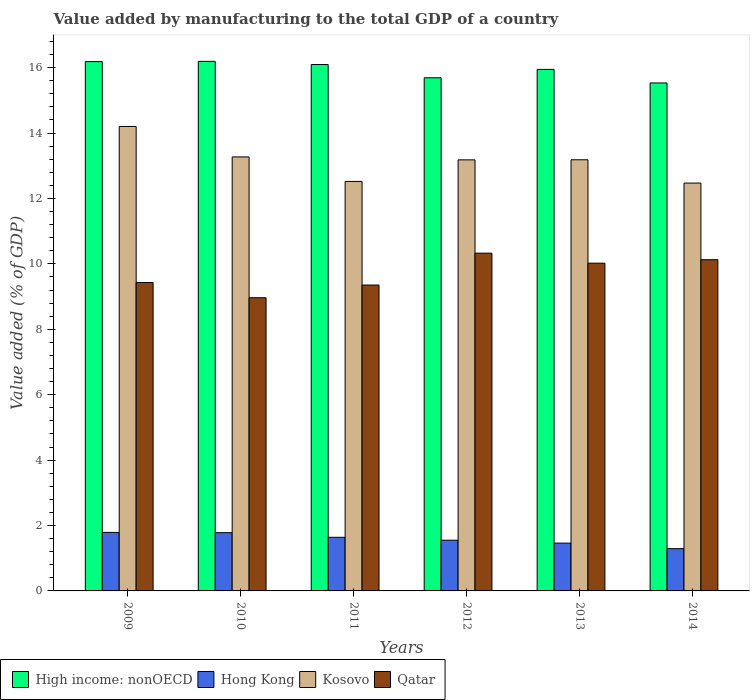Are the number of bars per tick equal to the number of legend labels?
Your answer should be compact. Yes. How many bars are there on the 2nd tick from the left?
Offer a terse response. 4. What is the value added by manufacturing to the total GDP in Qatar in 2009?
Provide a short and direct response. 9.43. Across all years, what is the maximum value added by manufacturing to the total GDP in Kosovo?
Offer a terse response. 14.2. Across all years, what is the minimum value added by manufacturing to the total GDP in Qatar?
Keep it short and to the point. 8.97. What is the total value added by manufacturing to the total GDP in Qatar in the graph?
Give a very brief answer. 58.23. What is the difference between the value added by manufacturing to the total GDP in High income: nonOECD in 2009 and that in 2014?
Provide a succinct answer. 0.65. What is the difference between the value added by manufacturing to the total GDP in High income: nonOECD in 2011 and the value added by manufacturing to the total GDP in Qatar in 2012?
Your answer should be compact. 5.77. What is the average value added by manufacturing to the total GDP in Hong Kong per year?
Provide a short and direct response. 1.59. In the year 2012, what is the difference between the value added by manufacturing to the total GDP in Qatar and value added by manufacturing to the total GDP in High income: nonOECD?
Your answer should be very brief. -5.36. What is the ratio of the value added by manufacturing to the total GDP in Qatar in 2010 to that in 2011?
Your answer should be compact. 0.96. What is the difference between the highest and the second highest value added by manufacturing to the total GDP in Qatar?
Your answer should be very brief. 0.2. What is the difference between the highest and the lowest value added by manufacturing to the total GDP in High income: nonOECD?
Your answer should be compact. 0.66. In how many years, is the value added by manufacturing to the total GDP in Kosovo greater than the average value added by manufacturing to the total GDP in Kosovo taken over all years?
Make the answer very short. 4. Is the sum of the value added by manufacturing to the total GDP in High income: nonOECD in 2012 and 2013 greater than the maximum value added by manufacturing to the total GDP in Qatar across all years?
Offer a terse response. Yes. What does the 4th bar from the left in 2011 represents?
Offer a terse response. Qatar. What does the 3rd bar from the right in 2012 represents?
Offer a terse response. Hong Kong. How many years are there in the graph?
Make the answer very short. 6. Where does the legend appear in the graph?
Your answer should be very brief. Bottom left. What is the title of the graph?
Give a very brief answer. Value added by manufacturing to the total GDP of a country. What is the label or title of the X-axis?
Offer a terse response. Years. What is the label or title of the Y-axis?
Provide a short and direct response. Value added (% of GDP). What is the Value added (% of GDP) in High income: nonOECD in 2009?
Ensure brevity in your answer.  16.19. What is the Value added (% of GDP) in Hong Kong in 2009?
Your answer should be compact. 1.79. What is the Value added (% of GDP) in Kosovo in 2009?
Make the answer very short. 14.2. What is the Value added (% of GDP) in Qatar in 2009?
Offer a terse response. 9.43. What is the Value added (% of GDP) in High income: nonOECD in 2010?
Make the answer very short. 16.19. What is the Value added (% of GDP) of Hong Kong in 2010?
Ensure brevity in your answer.  1.78. What is the Value added (% of GDP) in Kosovo in 2010?
Make the answer very short. 13.27. What is the Value added (% of GDP) of Qatar in 2010?
Offer a very short reply. 8.97. What is the Value added (% of GDP) of High income: nonOECD in 2011?
Provide a succinct answer. 16.1. What is the Value added (% of GDP) in Hong Kong in 2011?
Make the answer very short. 1.64. What is the Value added (% of GDP) in Kosovo in 2011?
Offer a terse response. 12.52. What is the Value added (% of GDP) of Qatar in 2011?
Your answer should be very brief. 9.35. What is the Value added (% of GDP) of High income: nonOECD in 2012?
Keep it short and to the point. 15.69. What is the Value added (% of GDP) in Hong Kong in 2012?
Ensure brevity in your answer.  1.55. What is the Value added (% of GDP) in Kosovo in 2012?
Ensure brevity in your answer.  13.18. What is the Value added (% of GDP) in Qatar in 2012?
Make the answer very short. 10.33. What is the Value added (% of GDP) of High income: nonOECD in 2013?
Offer a terse response. 15.95. What is the Value added (% of GDP) of Hong Kong in 2013?
Ensure brevity in your answer.  1.46. What is the Value added (% of GDP) of Kosovo in 2013?
Provide a succinct answer. 13.18. What is the Value added (% of GDP) of Qatar in 2013?
Give a very brief answer. 10.02. What is the Value added (% of GDP) of High income: nonOECD in 2014?
Keep it short and to the point. 15.53. What is the Value added (% of GDP) of Hong Kong in 2014?
Make the answer very short. 1.29. What is the Value added (% of GDP) in Kosovo in 2014?
Provide a succinct answer. 12.47. What is the Value added (% of GDP) of Qatar in 2014?
Offer a terse response. 10.13. Across all years, what is the maximum Value added (% of GDP) of High income: nonOECD?
Offer a very short reply. 16.19. Across all years, what is the maximum Value added (% of GDP) of Hong Kong?
Offer a very short reply. 1.79. Across all years, what is the maximum Value added (% of GDP) in Kosovo?
Your answer should be compact. 14.2. Across all years, what is the maximum Value added (% of GDP) in Qatar?
Offer a terse response. 10.33. Across all years, what is the minimum Value added (% of GDP) of High income: nonOECD?
Your answer should be compact. 15.53. Across all years, what is the minimum Value added (% of GDP) of Hong Kong?
Your answer should be compact. 1.29. Across all years, what is the minimum Value added (% of GDP) in Kosovo?
Offer a very short reply. 12.47. Across all years, what is the minimum Value added (% of GDP) in Qatar?
Offer a very short reply. 8.97. What is the total Value added (% of GDP) in High income: nonOECD in the graph?
Provide a short and direct response. 95.64. What is the total Value added (% of GDP) of Hong Kong in the graph?
Keep it short and to the point. 9.51. What is the total Value added (% of GDP) in Kosovo in the graph?
Your answer should be compact. 78.83. What is the total Value added (% of GDP) in Qatar in the graph?
Provide a short and direct response. 58.23. What is the difference between the Value added (% of GDP) in High income: nonOECD in 2009 and that in 2010?
Provide a succinct answer. -0.01. What is the difference between the Value added (% of GDP) in Hong Kong in 2009 and that in 2010?
Provide a short and direct response. 0.01. What is the difference between the Value added (% of GDP) of Kosovo in 2009 and that in 2010?
Keep it short and to the point. 0.93. What is the difference between the Value added (% of GDP) in Qatar in 2009 and that in 2010?
Offer a terse response. 0.46. What is the difference between the Value added (% of GDP) in High income: nonOECD in 2009 and that in 2011?
Keep it short and to the point. 0.09. What is the difference between the Value added (% of GDP) in Kosovo in 2009 and that in 2011?
Give a very brief answer. 1.68. What is the difference between the Value added (% of GDP) of Qatar in 2009 and that in 2011?
Offer a terse response. 0.08. What is the difference between the Value added (% of GDP) in High income: nonOECD in 2009 and that in 2012?
Keep it short and to the point. 0.5. What is the difference between the Value added (% of GDP) in Hong Kong in 2009 and that in 2012?
Offer a very short reply. 0.24. What is the difference between the Value added (% of GDP) in Kosovo in 2009 and that in 2012?
Offer a terse response. 1.02. What is the difference between the Value added (% of GDP) of Qatar in 2009 and that in 2012?
Give a very brief answer. -0.9. What is the difference between the Value added (% of GDP) in High income: nonOECD in 2009 and that in 2013?
Keep it short and to the point. 0.24. What is the difference between the Value added (% of GDP) in Hong Kong in 2009 and that in 2013?
Your answer should be very brief. 0.33. What is the difference between the Value added (% of GDP) of Kosovo in 2009 and that in 2013?
Your answer should be compact. 1.02. What is the difference between the Value added (% of GDP) in Qatar in 2009 and that in 2013?
Provide a succinct answer. -0.59. What is the difference between the Value added (% of GDP) of High income: nonOECD in 2009 and that in 2014?
Offer a very short reply. 0.65. What is the difference between the Value added (% of GDP) of Hong Kong in 2009 and that in 2014?
Your response must be concise. 0.5. What is the difference between the Value added (% of GDP) in Kosovo in 2009 and that in 2014?
Your answer should be very brief. 1.73. What is the difference between the Value added (% of GDP) in Qatar in 2009 and that in 2014?
Your answer should be very brief. -0.7. What is the difference between the Value added (% of GDP) in High income: nonOECD in 2010 and that in 2011?
Ensure brevity in your answer.  0.1. What is the difference between the Value added (% of GDP) in Hong Kong in 2010 and that in 2011?
Provide a short and direct response. 0.14. What is the difference between the Value added (% of GDP) in Kosovo in 2010 and that in 2011?
Keep it short and to the point. 0.75. What is the difference between the Value added (% of GDP) in Qatar in 2010 and that in 2011?
Your answer should be compact. -0.39. What is the difference between the Value added (% of GDP) of High income: nonOECD in 2010 and that in 2012?
Offer a very short reply. 0.5. What is the difference between the Value added (% of GDP) in Hong Kong in 2010 and that in 2012?
Offer a terse response. 0.23. What is the difference between the Value added (% of GDP) of Kosovo in 2010 and that in 2012?
Offer a very short reply. 0.09. What is the difference between the Value added (% of GDP) in Qatar in 2010 and that in 2012?
Ensure brevity in your answer.  -1.36. What is the difference between the Value added (% of GDP) of High income: nonOECD in 2010 and that in 2013?
Your response must be concise. 0.25. What is the difference between the Value added (% of GDP) in Hong Kong in 2010 and that in 2013?
Ensure brevity in your answer.  0.32. What is the difference between the Value added (% of GDP) of Kosovo in 2010 and that in 2013?
Make the answer very short. 0.09. What is the difference between the Value added (% of GDP) in Qatar in 2010 and that in 2013?
Give a very brief answer. -1.06. What is the difference between the Value added (% of GDP) of High income: nonOECD in 2010 and that in 2014?
Provide a short and direct response. 0.66. What is the difference between the Value added (% of GDP) of Hong Kong in 2010 and that in 2014?
Provide a succinct answer. 0.49. What is the difference between the Value added (% of GDP) of Qatar in 2010 and that in 2014?
Provide a succinct answer. -1.16. What is the difference between the Value added (% of GDP) in High income: nonOECD in 2011 and that in 2012?
Offer a very short reply. 0.4. What is the difference between the Value added (% of GDP) in Hong Kong in 2011 and that in 2012?
Ensure brevity in your answer.  0.09. What is the difference between the Value added (% of GDP) in Kosovo in 2011 and that in 2012?
Your answer should be very brief. -0.66. What is the difference between the Value added (% of GDP) in Qatar in 2011 and that in 2012?
Give a very brief answer. -0.98. What is the difference between the Value added (% of GDP) of High income: nonOECD in 2011 and that in 2013?
Your response must be concise. 0.15. What is the difference between the Value added (% of GDP) of Hong Kong in 2011 and that in 2013?
Keep it short and to the point. 0.18. What is the difference between the Value added (% of GDP) in Kosovo in 2011 and that in 2013?
Your answer should be very brief. -0.66. What is the difference between the Value added (% of GDP) of Qatar in 2011 and that in 2013?
Your answer should be compact. -0.67. What is the difference between the Value added (% of GDP) in High income: nonOECD in 2011 and that in 2014?
Your response must be concise. 0.56. What is the difference between the Value added (% of GDP) in Hong Kong in 2011 and that in 2014?
Ensure brevity in your answer.  0.35. What is the difference between the Value added (% of GDP) in Kosovo in 2011 and that in 2014?
Ensure brevity in your answer.  0.05. What is the difference between the Value added (% of GDP) in Qatar in 2011 and that in 2014?
Your answer should be compact. -0.77. What is the difference between the Value added (% of GDP) in High income: nonOECD in 2012 and that in 2013?
Provide a succinct answer. -0.26. What is the difference between the Value added (% of GDP) of Hong Kong in 2012 and that in 2013?
Keep it short and to the point. 0.09. What is the difference between the Value added (% of GDP) in Kosovo in 2012 and that in 2013?
Offer a very short reply. -0. What is the difference between the Value added (% of GDP) of Qatar in 2012 and that in 2013?
Offer a very short reply. 0.31. What is the difference between the Value added (% of GDP) in High income: nonOECD in 2012 and that in 2014?
Provide a short and direct response. 0.16. What is the difference between the Value added (% of GDP) of Hong Kong in 2012 and that in 2014?
Provide a succinct answer. 0.26. What is the difference between the Value added (% of GDP) in Kosovo in 2012 and that in 2014?
Your answer should be very brief. 0.71. What is the difference between the Value added (% of GDP) of Qatar in 2012 and that in 2014?
Keep it short and to the point. 0.2. What is the difference between the Value added (% of GDP) in High income: nonOECD in 2013 and that in 2014?
Make the answer very short. 0.41. What is the difference between the Value added (% of GDP) of Hong Kong in 2013 and that in 2014?
Provide a succinct answer. 0.17. What is the difference between the Value added (% of GDP) in Kosovo in 2013 and that in 2014?
Your answer should be compact. 0.71. What is the difference between the Value added (% of GDP) in Qatar in 2013 and that in 2014?
Keep it short and to the point. -0.11. What is the difference between the Value added (% of GDP) in High income: nonOECD in 2009 and the Value added (% of GDP) in Hong Kong in 2010?
Your response must be concise. 14.41. What is the difference between the Value added (% of GDP) in High income: nonOECD in 2009 and the Value added (% of GDP) in Kosovo in 2010?
Keep it short and to the point. 2.92. What is the difference between the Value added (% of GDP) of High income: nonOECD in 2009 and the Value added (% of GDP) of Qatar in 2010?
Make the answer very short. 7.22. What is the difference between the Value added (% of GDP) in Hong Kong in 2009 and the Value added (% of GDP) in Kosovo in 2010?
Provide a succinct answer. -11.48. What is the difference between the Value added (% of GDP) in Hong Kong in 2009 and the Value added (% of GDP) in Qatar in 2010?
Ensure brevity in your answer.  -7.18. What is the difference between the Value added (% of GDP) in Kosovo in 2009 and the Value added (% of GDP) in Qatar in 2010?
Make the answer very short. 5.24. What is the difference between the Value added (% of GDP) in High income: nonOECD in 2009 and the Value added (% of GDP) in Hong Kong in 2011?
Offer a terse response. 14.55. What is the difference between the Value added (% of GDP) in High income: nonOECD in 2009 and the Value added (% of GDP) in Kosovo in 2011?
Your response must be concise. 3.66. What is the difference between the Value added (% of GDP) in High income: nonOECD in 2009 and the Value added (% of GDP) in Qatar in 2011?
Your response must be concise. 6.83. What is the difference between the Value added (% of GDP) in Hong Kong in 2009 and the Value added (% of GDP) in Kosovo in 2011?
Provide a succinct answer. -10.73. What is the difference between the Value added (% of GDP) of Hong Kong in 2009 and the Value added (% of GDP) of Qatar in 2011?
Give a very brief answer. -7.56. What is the difference between the Value added (% of GDP) in Kosovo in 2009 and the Value added (% of GDP) in Qatar in 2011?
Offer a terse response. 4.85. What is the difference between the Value added (% of GDP) in High income: nonOECD in 2009 and the Value added (% of GDP) in Hong Kong in 2012?
Make the answer very short. 14.64. What is the difference between the Value added (% of GDP) of High income: nonOECD in 2009 and the Value added (% of GDP) of Kosovo in 2012?
Your answer should be compact. 3. What is the difference between the Value added (% of GDP) of High income: nonOECD in 2009 and the Value added (% of GDP) of Qatar in 2012?
Provide a succinct answer. 5.86. What is the difference between the Value added (% of GDP) in Hong Kong in 2009 and the Value added (% of GDP) in Kosovo in 2012?
Make the answer very short. -11.39. What is the difference between the Value added (% of GDP) in Hong Kong in 2009 and the Value added (% of GDP) in Qatar in 2012?
Make the answer very short. -8.54. What is the difference between the Value added (% of GDP) of Kosovo in 2009 and the Value added (% of GDP) of Qatar in 2012?
Offer a very short reply. 3.87. What is the difference between the Value added (% of GDP) of High income: nonOECD in 2009 and the Value added (% of GDP) of Hong Kong in 2013?
Provide a succinct answer. 14.72. What is the difference between the Value added (% of GDP) of High income: nonOECD in 2009 and the Value added (% of GDP) of Kosovo in 2013?
Keep it short and to the point. 3. What is the difference between the Value added (% of GDP) in High income: nonOECD in 2009 and the Value added (% of GDP) in Qatar in 2013?
Provide a short and direct response. 6.16. What is the difference between the Value added (% of GDP) of Hong Kong in 2009 and the Value added (% of GDP) of Kosovo in 2013?
Ensure brevity in your answer.  -11.39. What is the difference between the Value added (% of GDP) of Hong Kong in 2009 and the Value added (% of GDP) of Qatar in 2013?
Offer a very short reply. -8.23. What is the difference between the Value added (% of GDP) in Kosovo in 2009 and the Value added (% of GDP) in Qatar in 2013?
Your answer should be very brief. 4.18. What is the difference between the Value added (% of GDP) of High income: nonOECD in 2009 and the Value added (% of GDP) of Hong Kong in 2014?
Your response must be concise. 14.89. What is the difference between the Value added (% of GDP) in High income: nonOECD in 2009 and the Value added (% of GDP) in Kosovo in 2014?
Offer a terse response. 3.72. What is the difference between the Value added (% of GDP) of High income: nonOECD in 2009 and the Value added (% of GDP) of Qatar in 2014?
Keep it short and to the point. 6.06. What is the difference between the Value added (% of GDP) of Hong Kong in 2009 and the Value added (% of GDP) of Kosovo in 2014?
Your answer should be compact. -10.68. What is the difference between the Value added (% of GDP) in Hong Kong in 2009 and the Value added (% of GDP) in Qatar in 2014?
Ensure brevity in your answer.  -8.34. What is the difference between the Value added (% of GDP) in Kosovo in 2009 and the Value added (% of GDP) in Qatar in 2014?
Provide a succinct answer. 4.07. What is the difference between the Value added (% of GDP) of High income: nonOECD in 2010 and the Value added (% of GDP) of Hong Kong in 2011?
Provide a short and direct response. 14.55. What is the difference between the Value added (% of GDP) in High income: nonOECD in 2010 and the Value added (% of GDP) in Kosovo in 2011?
Your answer should be very brief. 3.67. What is the difference between the Value added (% of GDP) of High income: nonOECD in 2010 and the Value added (% of GDP) of Qatar in 2011?
Provide a short and direct response. 6.84. What is the difference between the Value added (% of GDP) of Hong Kong in 2010 and the Value added (% of GDP) of Kosovo in 2011?
Provide a short and direct response. -10.74. What is the difference between the Value added (% of GDP) in Hong Kong in 2010 and the Value added (% of GDP) in Qatar in 2011?
Your answer should be compact. -7.57. What is the difference between the Value added (% of GDP) of Kosovo in 2010 and the Value added (% of GDP) of Qatar in 2011?
Provide a succinct answer. 3.92. What is the difference between the Value added (% of GDP) in High income: nonOECD in 2010 and the Value added (% of GDP) in Hong Kong in 2012?
Provide a succinct answer. 14.64. What is the difference between the Value added (% of GDP) in High income: nonOECD in 2010 and the Value added (% of GDP) in Kosovo in 2012?
Your response must be concise. 3.01. What is the difference between the Value added (% of GDP) of High income: nonOECD in 2010 and the Value added (% of GDP) of Qatar in 2012?
Your response must be concise. 5.86. What is the difference between the Value added (% of GDP) of Hong Kong in 2010 and the Value added (% of GDP) of Kosovo in 2012?
Give a very brief answer. -11.4. What is the difference between the Value added (% of GDP) in Hong Kong in 2010 and the Value added (% of GDP) in Qatar in 2012?
Keep it short and to the point. -8.55. What is the difference between the Value added (% of GDP) of Kosovo in 2010 and the Value added (% of GDP) of Qatar in 2012?
Offer a very short reply. 2.94. What is the difference between the Value added (% of GDP) of High income: nonOECD in 2010 and the Value added (% of GDP) of Hong Kong in 2013?
Give a very brief answer. 14.73. What is the difference between the Value added (% of GDP) of High income: nonOECD in 2010 and the Value added (% of GDP) of Kosovo in 2013?
Keep it short and to the point. 3.01. What is the difference between the Value added (% of GDP) of High income: nonOECD in 2010 and the Value added (% of GDP) of Qatar in 2013?
Your answer should be compact. 6.17. What is the difference between the Value added (% of GDP) in Hong Kong in 2010 and the Value added (% of GDP) in Kosovo in 2013?
Your response must be concise. -11.4. What is the difference between the Value added (% of GDP) of Hong Kong in 2010 and the Value added (% of GDP) of Qatar in 2013?
Make the answer very short. -8.24. What is the difference between the Value added (% of GDP) in Kosovo in 2010 and the Value added (% of GDP) in Qatar in 2013?
Keep it short and to the point. 3.25. What is the difference between the Value added (% of GDP) of High income: nonOECD in 2010 and the Value added (% of GDP) of Hong Kong in 2014?
Provide a succinct answer. 14.9. What is the difference between the Value added (% of GDP) in High income: nonOECD in 2010 and the Value added (% of GDP) in Kosovo in 2014?
Your answer should be compact. 3.72. What is the difference between the Value added (% of GDP) of High income: nonOECD in 2010 and the Value added (% of GDP) of Qatar in 2014?
Make the answer very short. 6.07. What is the difference between the Value added (% of GDP) of Hong Kong in 2010 and the Value added (% of GDP) of Kosovo in 2014?
Give a very brief answer. -10.69. What is the difference between the Value added (% of GDP) of Hong Kong in 2010 and the Value added (% of GDP) of Qatar in 2014?
Give a very brief answer. -8.35. What is the difference between the Value added (% of GDP) in Kosovo in 2010 and the Value added (% of GDP) in Qatar in 2014?
Your answer should be very brief. 3.14. What is the difference between the Value added (% of GDP) in High income: nonOECD in 2011 and the Value added (% of GDP) in Hong Kong in 2012?
Make the answer very short. 14.54. What is the difference between the Value added (% of GDP) in High income: nonOECD in 2011 and the Value added (% of GDP) in Kosovo in 2012?
Your answer should be compact. 2.91. What is the difference between the Value added (% of GDP) in High income: nonOECD in 2011 and the Value added (% of GDP) in Qatar in 2012?
Ensure brevity in your answer.  5.77. What is the difference between the Value added (% of GDP) in Hong Kong in 2011 and the Value added (% of GDP) in Kosovo in 2012?
Provide a succinct answer. -11.54. What is the difference between the Value added (% of GDP) of Hong Kong in 2011 and the Value added (% of GDP) of Qatar in 2012?
Provide a short and direct response. -8.69. What is the difference between the Value added (% of GDP) in Kosovo in 2011 and the Value added (% of GDP) in Qatar in 2012?
Ensure brevity in your answer.  2.19. What is the difference between the Value added (% of GDP) in High income: nonOECD in 2011 and the Value added (% of GDP) in Hong Kong in 2013?
Ensure brevity in your answer.  14.63. What is the difference between the Value added (% of GDP) in High income: nonOECD in 2011 and the Value added (% of GDP) in Kosovo in 2013?
Offer a very short reply. 2.91. What is the difference between the Value added (% of GDP) of High income: nonOECD in 2011 and the Value added (% of GDP) of Qatar in 2013?
Your response must be concise. 6.07. What is the difference between the Value added (% of GDP) in Hong Kong in 2011 and the Value added (% of GDP) in Kosovo in 2013?
Provide a short and direct response. -11.54. What is the difference between the Value added (% of GDP) in Hong Kong in 2011 and the Value added (% of GDP) in Qatar in 2013?
Provide a short and direct response. -8.38. What is the difference between the Value added (% of GDP) of Kosovo in 2011 and the Value added (% of GDP) of Qatar in 2013?
Provide a succinct answer. 2.5. What is the difference between the Value added (% of GDP) of High income: nonOECD in 2011 and the Value added (% of GDP) of Hong Kong in 2014?
Provide a short and direct response. 14.8. What is the difference between the Value added (% of GDP) of High income: nonOECD in 2011 and the Value added (% of GDP) of Kosovo in 2014?
Keep it short and to the point. 3.62. What is the difference between the Value added (% of GDP) of High income: nonOECD in 2011 and the Value added (% of GDP) of Qatar in 2014?
Your answer should be very brief. 5.97. What is the difference between the Value added (% of GDP) in Hong Kong in 2011 and the Value added (% of GDP) in Kosovo in 2014?
Give a very brief answer. -10.83. What is the difference between the Value added (% of GDP) of Hong Kong in 2011 and the Value added (% of GDP) of Qatar in 2014?
Give a very brief answer. -8.49. What is the difference between the Value added (% of GDP) of Kosovo in 2011 and the Value added (% of GDP) of Qatar in 2014?
Make the answer very short. 2.39. What is the difference between the Value added (% of GDP) in High income: nonOECD in 2012 and the Value added (% of GDP) in Hong Kong in 2013?
Offer a terse response. 14.23. What is the difference between the Value added (% of GDP) in High income: nonOECD in 2012 and the Value added (% of GDP) in Kosovo in 2013?
Provide a succinct answer. 2.51. What is the difference between the Value added (% of GDP) of High income: nonOECD in 2012 and the Value added (% of GDP) of Qatar in 2013?
Ensure brevity in your answer.  5.67. What is the difference between the Value added (% of GDP) in Hong Kong in 2012 and the Value added (% of GDP) in Kosovo in 2013?
Your answer should be compact. -11.63. What is the difference between the Value added (% of GDP) in Hong Kong in 2012 and the Value added (% of GDP) in Qatar in 2013?
Provide a short and direct response. -8.47. What is the difference between the Value added (% of GDP) of Kosovo in 2012 and the Value added (% of GDP) of Qatar in 2013?
Keep it short and to the point. 3.16. What is the difference between the Value added (% of GDP) in High income: nonOECD in 2012 and the Value added (% of GDP) in Hong Kong in 2014?
Provide a succinct answer. 14.4. What is the difference between the Value added (% of GDP) in High income: nonOECD in 2012 and the Value added (% of GDP) in Kosovo in 2014?
Ensure brevity in your answer.  3.22. What is the difference between the Value added (% of GDP) of High income: nonOECD in 2012 and the Value added (% of GDP) of Qatar in 2014?
Provide a succinct answer. 5.56. What is the difference between the Value added (% of GDP) in Hong Kong in 2012 and the Value added (% of GDP) in Kosovo in 2014?
Your response must be concise. -10.92. What is the difference between the Value added (% of GDP) of Hong Kong in 2012 and the Value added (% of GDP) of Qatar in 2014?
Provide a succinct answer. -8.58. What is the difference between the Value added (% of GDP) of Kosovo in 2012 and the Value added (% of GDP) of Qatar in 2014?
Ensure brevity in your answer.  3.05. What is the difference between the Value added (% of GDP) of High income: nonOECD in 2013 and the Value added (% of GDP) of Hong Kong in 2014?
Offer a very short reply. 14.66. What is the difference between the Value added (% of GDP) of High income: nonOECD in 2013 and the Value added (% of GDP) of Kosovo in 2014?
Keep it short and to the point. 3.48. What is the difference between the Value added (% of GDP) in High income: nonOECD in 2013 and the Value added (% of GDP) in Qatar in 2014?
Your answer should be compact. 5.82. What is the difference between the Value added (% of GDP) of Hong Kong in 2013 and the Value added (% of GDP) of Kosovo in 2014?
Provide a succinct answer. -11.01. What is the difference between the Value added (% of GDP) in Hong Kong in 2013 and the Value added (% of GDP) in Qatar in 2014?
Keep it short and to the point. -8.67. What is the difference between the Value added (% of GDP) in Kosovo in 2013 and the Value added (% of GDP) in Qatar in 2014?
Offer a terse response. 3.06. What is the average Value added (% of GDP) of High income: nonOECD per year?
Provide a succinct answer. 15.94. What is the average Value added (% of GDP) of Hong Kong per year?
Give a very brief answer. 1.59. What is the average Value added (% of GDP) of Kosovo per year?
Provide a short and direct response. 13.14. What is the average Value added (% of GDP) of Qatar per year?
Provide a succinct answer. 9.7. In the year 2009, what is the difference between the Value added (% of GDP) in High income: nonOECD and Value added (% of GDP) in Hong Kong?
Your answer should be compact. 14.4. In the year 2009, what is the difference between the Value added (% of GDP) of High income: nonOECD and Value added (% of GDP) of Kosovo?
Offer a terse response. 1.98. In the year 2009, what is the difference between the Value added (% of GDP) of High income: nonOECD and Value added (% of GDP) of Qatar?
Make the answer very short. 6.76. In the year 2009, what is the difference between the Value added (% of GDP) of Hong Kong and Value added (% of GDP) of Kosovo?
Provide a succinct answer. -12.41. In the year 2009, what is the difference between the Value added (% of GDP) in Hong Kong and Value added (% of GDP) in Qatar?
Offer a very short reply. -7.64. In the year 2009, what is the difference between the Value added (% of GDP) of Kosovo and Value added (% of GDP) of Qatar?
Make the answer very short. 4.77. In the year 2010, what is the difference between the Value added (% of GDP) of High income: nonOECD and Value added (% of GDP) of Hong Kong?
Give a very brief answer. 14.41. In the year 2010, what is the difference between the Value added (% of GDP) in High income: nonOECD and Value added (% of GDP) in Kosovo?
Your response must be concise. 2.92. In the year 2010, what is the difference between the Value added (% of GDP) in High income: nonOECD and Value added (% of GDP) in Qatar?
Ensure brevity in your answer.  7.23. In the year 2010, what is the difference between the Value added (% of GDP) in Hong Kong and Value added (% of GDP) in Kosovo?
Ensure brevity in your answer.  -11.49. In the year 2010, what is the difference between the Value added (% of GDP) in Hong Kong and Value added (% of GDP) in Qatar?
Ensure brevity in your answer.  -7.18. In the year 2010, what is the difference between the Value added (% of GDP) of Kosovo and Value added (% of GDP) of Qatar?
Provide a succinct answer. 4.31. In the year 2011, what is the difference between the Value added (% of GDP) in High income: nonOECD and Value added (% of GDP) in Hong Kong?
Give a very brief answer. 14.46. In the year 2011, what is the difference between the Value added (% of GDP) in High income: nonOECD and Value added (% of GDP) in Kosovo?
Offer a very short reply. 3.57. In the year 2011, what is the difference between the Value added (% of GDP) in High income: nonOECD and Value added (% of GDP) in Qatar?
Make the answer very short. 6.74. In the year 2011, what is the difference between the Value added (% of GDP) in Hong Kong and Value added (% of GDP) in Kosovo?
Your response must be concise. -10.88. In the year 2011, what is the difference between the Value added (% of GDP) in Hong Kong and Value added (% of GDP) in Qatar?
Your answer should be compact. -7.71. In the year 2011, what is the difference between the Value added (% of GDP) in Kosovo and Value added (% of GDP) in Qatar?
Offer a terse response. 3.17. In the year 2012, what is the difference between the Value added (% of GDP) in High income: nonOECD and Value added (% of GDP) in Hong Kong?
Ensure brevity in your answer.  14.14. In the year 2012, what is the difference between the Value added (% of GDP) in High income: nonOECD and Value added (% of GDP) in Kosovo?
Provide a succinct answer. 2.51. In the year 2012, what is the difference between the Value added (% of GDP) in High income: nonOECD and Value added (% of GDP) in Qatar?
Your answer should be compact. 5.36. In the year 2012, what is the difference between the Value added (% of GDP) of Hong Kong and Value added (% of GDP) of Kosovo?
Give a very brief answer. -11.63. In the year 2012, what is the difference between the Value added (% of GDP) in Hong Kong and Value added (% of GDP) in Qatar?
Your response must be concise. -8.78. In the year 2012, what is the difference between the Value added (% of GDP) of Kosovo and Value added (% of GDP) of Qatar?
Give a very brief answer. 2.85. In the year 2013, what is the difference between the Value added (% of GDP) of High income: nonOECD and Value added (% of GDP) of Hong Kong?
Ensure brevity in your answer.  14.49. In the year 2013, what is the difference between the Value added (% of GDP) of High income: nonOECD and Value added (% of GDP) of Kosovo?
Offer a terse response. 2.76. In the year 2013, what is the difference between the Value added (% of GDP) of High income: nonOECD and Value added (% of GDP) of Qatar?
Provide a short and direct response. 5.93. In the year 2013, what is the difference between the Value added (% of GDP) of Hong Kong and Value added (% of GDP) of Kosovo?
Give a very brief answer. -11.72. In the year 2013, what is the difference between the Value added (% of GDP) of Hong Kong and Value added (% of GDP) of Qatar?
Give a very brief answer. -8.56. In the year 2013, what is the difference between the Value added (% of GDP) of Kosovo and Value added (% of GDP) of Qatar?
Your answer should be very brief. 3.16. In the year 2014, what is the difference between the Value added (% of GDP) of High income: nonOECD and Value added (% of GDP) of Hong Kong?
Give a very brief answer. 14.24. In the year 2014, what is the difference between the Value added (% of GDP) of High income: nonOECD and Value added (% of GDP) of Kosovo?
Your response must be concise. 3.06. In the year 2014, what is the difference between the Value added (% of GDP) in High income: nonOECD and Value added (% of GDP) in Qatar?
Your answer should be very brief. 5.4. In the year 2014, what is the difference between the Value added (% of GDP) in Hong Kong and Value added (% of GDP) in Kosovo?
Provide a succinct answer. -11.18. In the year 2014, what is the difference between the Value added (% of GDP) of Hong Kong and Value added (% of GDP) of Qatar?
Provide a short and direct response. -8.84. In the year 2014, what is the difference between the Value added (% of GDP) in Kosovo and Value added (% of GDP) in Qatar?
Offer a terse response. 2.34. What is the ratio of the Value added (% of GDP) of High income: nonOECD in 2009 to that in 2010?
Ensure brevity in your answer.  1. What is the ratio of the Value added (% of GDP) in Hong Kong in 2009 to that in 2010?
Give a very brief answer. 1. What is the ratio of the Value added (% of GDP) of Kosovo in 2009 to that in 2010?
Your response must be concise. 1.07. What is the ratio of the Value added (% of GDP) in Qatar in 2009 to that in 2010?
Offer a terse response. 1.05. What is the ratio of the Value added (% of GDP) of High income: nonOECD in 2009 to that in 2011?
Ensure brevity in your answer.  1.01. What is the ratio of the Value added (% of GDP) in Hong Kong in 2009 to that in 2011?
Offer a terse response. 1.09. What is the ratio of the Value added (% of GDP) in Kosovo in 2009 to that in 2011?
Your answer should be compact. 1.13. What is the ratio of the Value added (% of GDP) of Qatar in 2009 to that in 2011?
Provide a succinct answer. 1.01. What is the ratio of the Value added (% of GDP) of High income: nonOECD in 2009 to that in 2012?
Provide a short and direct response. 1.03. What is the ratio of the Value added (% of GDP) of Hong Kong in 2009 to that in 2012?
Your response must be concise. 1.15. What is the ratio of the Value added (% of GDP) in Kosovo in 2009 to that in 2012?
Ensure brevity in your answer.  1.08. What is the ratio of the Value added (% of GDP) of Qatar in 2009 to that in 2012?
Keep it short and to the point. 0.91. What is the ratio of the Value added (% of GDP) in High income: nonOECD in 2009 to that in 2013?
Give a very brief answer. 1.01. What is the ratio of the Value added (% of GDP) of Hong Kong in 2009 to that in 2013?
Offer a terse response. 1.22. What is the ratio of the Value added (% of GDP) in Kosovo in 2009 to that in 2013?
Your answer should be compact. 1.08. What is the ratio of the Value added (% of GDP) of Qatar in 2009 to that in 2013?
Offer a very short reply. 0.94. What is the ratio of the Value added (% of GDP) of High income: nonOECD in 2009 to that in 2014?
Give a very brief answer. 1.04. What is the ratio of the Value added (% of GDP) of Hong Kong in 2009 to that in 2014?
Keep it short and to the point. 1.39. What is the ratio of the Value added (% of GDP) in Kosovo in 2009 to that in 2014?
Keep it short and to the point. 1.14. What is the ratio of the Value added (% of GDP) in Qatar in 2009 to that in 2014?
Offer a very short reply. 0.93. What is the ratio of the Value added (% of GDP) of Hong Kong in 2010 to that in 2011?
Provide a short and direct response. 1.09. What is the ratio of the Value added (% of GDP) in Kosovo in 2010 to that in 2011?
Give a very brief answer. 1.06. What is the ratio of the Value added (% of GDP) of Qatar in 2010 to that in 2011?
Your response must be concise. 0.96. What is the ratio of the Value added (% of GDP) in High income: nonOECD in 2010 to that in 2012?
Offer a very short reply. 1.03. What is the ratio of the Value added (% of GDP) of Hong Kong in 2010 to that in 2012?
Your answer should be very brief. 1.15. What is the ratio of the Value added (% of GDP) of Kosovo in 2010 to that in 2012?
Give a very brief answer. 1.01. What is the ratio of the Value added (% of GDP) in Qatar in 2010 to that in 2012?
Offer a terse response. 0.87. What is the ratio of the Value added (% of GDP) of High income: nonOECD in 2010 to that in 2013?
Offer a very short reply. 1.02. What is the ratio of the Value added (% of GDP) of Hong Kong in 2010 to that in 2013?
Ensure brevity in your answer.  1.22. What is the ratio of the Value added (% of GDP) in Kosovo in 2010 to that in 2013?
Provide a short and direct response. 1.01. What is the ratio of the Value added (% of GDP) of Qatar in 2010 to that in 2013?
Ensure brevity in your answer.  0.89. What is the ratio of the Value added (% of GDP) in High income: nonOECD in 2010 to that in 2014?
Offer a very short reply. 1.04. What is the ratio of the Value added (% of GDP) of Hong Kong in 2010 to that in 2014?
Ensure brevity in your answer.  1.38. What is the ratio of the Value added (% of GDP) of Kosovo in 2010 to that in 2014?
Offer a very short reply. 1.06. What is the ratio of the Value added (% of GDP) of Qatar in 2010 to that in 2014?
Make the answer very short. 0.89. What is the ratio of the Value added (% of GDP) of High income: nonOECD in 2011 to that in 2012?
Your answer should be very brief. 1.03. What is the ratio of the Value added (% of GDP) of Hong Kong in 2011 to that in 2012?
Offer a very short reply. 1.06. What is the ratio of the Value added (% of GDP) in Kosovo in 2011 to that in 2012?
Make the answer very short. 0.95. What is the ratio of the Value added (% of GDP) in Qatar in 2011 to that in 2012?
Make the answer very short. 0.91. What is the ratio of the Value added (% of GDP) of High income: nonOECD in 2011 to that in 2013?
Your answer should be compact. 1.01. What is the ratio of the Value added (% of GDP) of Hong Kong in 2011 to that in 2013?
Provide a succinct answer. 1.12. What is the ratio of the Value added (% of GDP) in Kosovo in 2011 to that in 2013?
Provide a succinct answer. 0.95. What is the ratio of the Value added (% of GDP) of Qatar in 2011 to that in 2013?
Provide a succinct answer. 0.93. What is the ratio of the Value added (% of GDP) of High income: nonOECD in 2011 to that in 2014?
Your answer should be very brief. 1.04. What is the ratio of the Value added (% of GDP) of Hong Kong in 2011 to that in 2014?
Provide a succinct answer. 1.27. What is the ratio of the Value added (% of GDP) in Qatar in 2011 to that in 2014?
Your response must be concise. 0.92. What is the ratio of the Value added (% of GDP) in High income: nonOECD in 2012 to that in 2013?
Your answer should be very brief. 0.98. What is the ratio of the Value added (% of GDP) in Hong Kong in 2012 to that in 2013?
Your answer should be very brief. 1.06. What is the ratio of the Value added (% of GDP) in Kosovo in 2012 to that in 2013?
Keep it short and to the point. 1. What is the ratio of the Value added (% of GDP) in Qatar in 2012 to that in 2013?
Make the answer very short. 1.03. What is the ratio of the Value added (% of GDP) in High income: nonOECD in 2012 to that in 2014?
Your response must be concise. 1.01. What is the ratio of the Value added (% of GDP) in Hong Kong in 2012 to that in 2014?
Provide a succinct answer. 1.2. What is the ratio of the Value added (% of GDP) of Kosovo in 2012 to that in 2014?
Give a very brief answer. 1.06. What is the ratio of the Value added (% of GDP) of Qatar in 2012 to that in 2014?
Provide a short and direct response. 1.02. What is the ratio of the Value added (% of GDP) in High income: nonOECD in 2013 to that in 2014?
Your answer should be compact. 1.03. What is the ratio of the Value added (% of GDP) of Hong Kong in 2013 to that in 2014?
Your answer should be compact. 1.13. What is the ratio of the Value added (% of GDP) in Kosovo in 2013 to that in 2014?
Give a very brief answer. 1.06. What is the difference between the highest and the second highest Value added (% of GDP) in High income: nonOECD?
Offer a terse response. 0.01. What is the difference between the highest and the second highest Value added (% of GDP) of Hong Kong?
Provide a succinct answer. 0.01. What is the difference between the highest and the second highest Value added (% of GDP) of Kosovo?
Provide a succinct answer. 0.93. What is the difference between the highest and the second highest Value added (% of GDP) of Qatar?
Provide a succinct answer. 0.2. What is the difference between the highest and the lowest Value added (% of GDP) in High income: nonOECD?
Make the answer very short. 0.66. What is the difference between the highest and the lowest Value added (% of GDP) in Hong Kong?
Keep it short and to the point. 0.5. What is the difference between the highest and the lowest Value added (% of GDP) of Kosovo?
Provide a succinct answer. 1.73. What is the difference between the highest and the lowest Value added (% of GDP) in Qatar?
Ensure brevity in your answer.  1.36. 